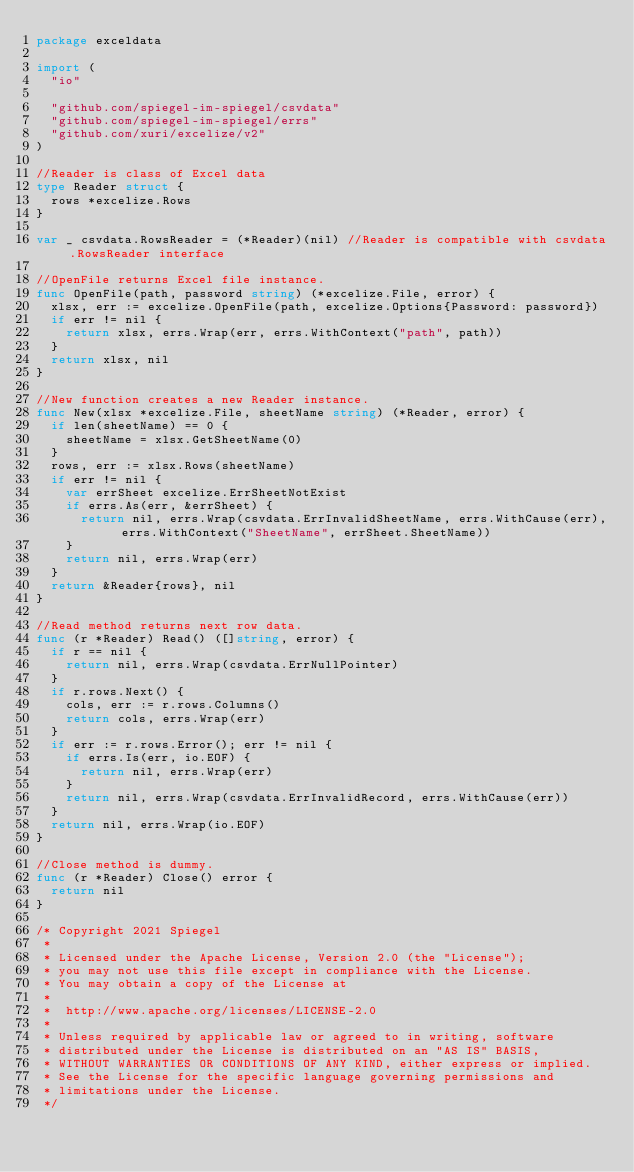Convert code to text. <code><loc_0><loc_0><loc_500><loc_500><_Go_>package exceldata

import (
	"io"

	"github.com/spiegel-im-spiegel/csvdata"
	"github.com/spiegel-im-spiegel/errs"
	"github.com/xuri/excelize/v2"
)

//Reader is class of Excel data
type Reader struct {
	rows *excelize.Rows
}

var _ csvdata.RowsReader = (*Reader)(nil) //Reader is compatible with csvdata.RowsReader interface

//OpenFile returns Excel file instance.
func OpenFile(path, password string) (*excelize.File, error) {
	xlsx, err := excelize.OpenFile(path, excelize.Options{Password: password})
	if err != nil {
		return xlsx, errs.Wrap(err, errs.WithContext("path", path))
	}
	return xlsx, nil
}

//New function creates a new Reader instance.
func New(xlsx *excelize.File, sheetName string) (*Reader, error) {
	if len(sheetName) == 0 {
		sheetName = xlsx.GetSheetName(0)
	}
	rows, err := xlsx.Rows(sheetName)
	if err != nil {
		var errSheet excelize.ErrSheetNotExist
		if errs.As(err, &errSheet) {
			return nil, errs.Wrap(csvdata.ErrInvalidSheetName, errs.WithCause(err), errs.WithContext("SheetName", errSheet.SheetName))
		}
		return nil, errs.Wrap(err)
	}
	return &Reader{rows}, nil
}

//Read method returns next row data.
func (r *Reader) Read() ([]string, error) {
	if r == nil {
		return nil, errs.Wrap(csvdata.ErrNullPointer)
	}
	if r.rows.Next() {
		cols, err := r.rows.Columns()
		return cols, errs.Wrap(err)
	}
	if err := r.rows.Error(); err != nil {
		if errs.Is(err, io.EOF) {
			return nil, errs.Wrap(err)
		}
		return nil, errs.Wrap(csvdata.ErrInvalidRecord, errs.WithCause(err))
	}
	return nil, errs.Wrap(io.EOF)
}

//Close method is dummy.
func (r *Reader) Close() error {
	return nil
}

/* Copyright 2021 Spiegel
 *
 * Licensed under the Apache License, Version 2.0 (the "License");
 * you may not use this file except in compliance with the License.
 * You may obtain a copy of the License at
 *
 * 	http://www.apache.org/licenses/LICENSE-2.0
 *
 * Unless required by applicable law or agreed to in writing, software
 * distributed under the License is distributed on an "AS IS" BASIS,
 * WITHOUT WARRANTIES OR CONDITIONS OF ANY KIND, either express or implied.
 * See the License for the specific language governing permissions and
 * limitations under the License.
 */
</code> 